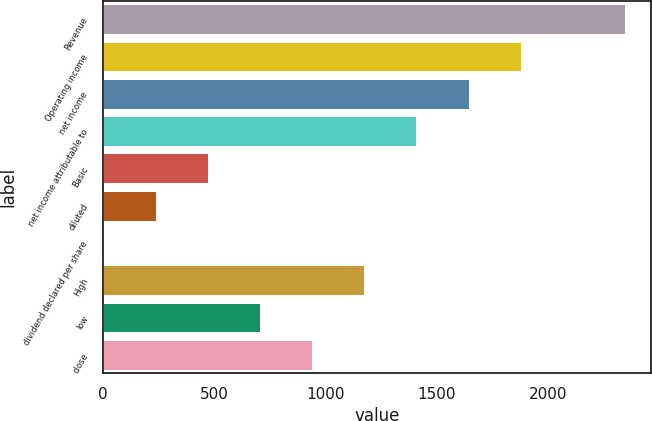Convert chart. <chart><loc_0><loc_0><loc_500><loc_500><bar_chart><fcel>Revenue<fcel>Operating income<fcel>net income<fcel>net income attributable to<fcel>Basic<fcel>diluted<fcel>dividend declared per share<fcel>High<fcel>low<fcel>close<nl><fcel>2347<fcel>1877.86<fcel>1643.3<fcel>1408.74<fcel>470.5<fcel>235.94<fcel>1.38<fcel>1174.18<fcel>705.06<fcel>939.62<nl></chart> 